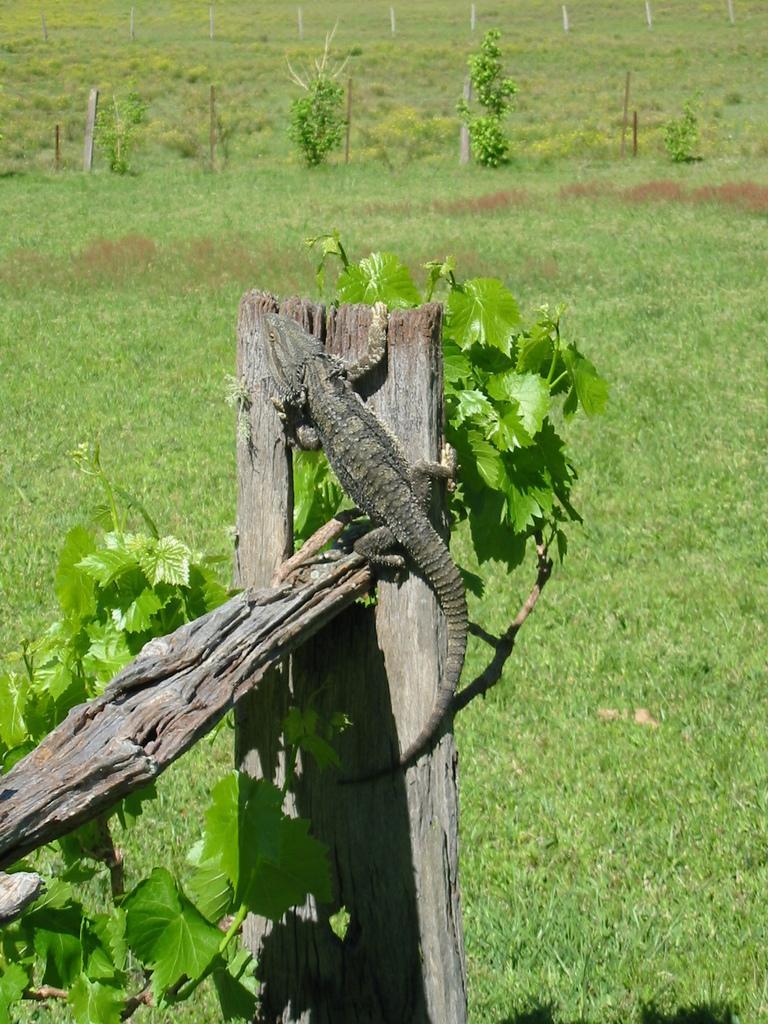Please provide a concise description of this image. It is a monitor lizard on the wooden plank. There are trees at the backside of an image. 